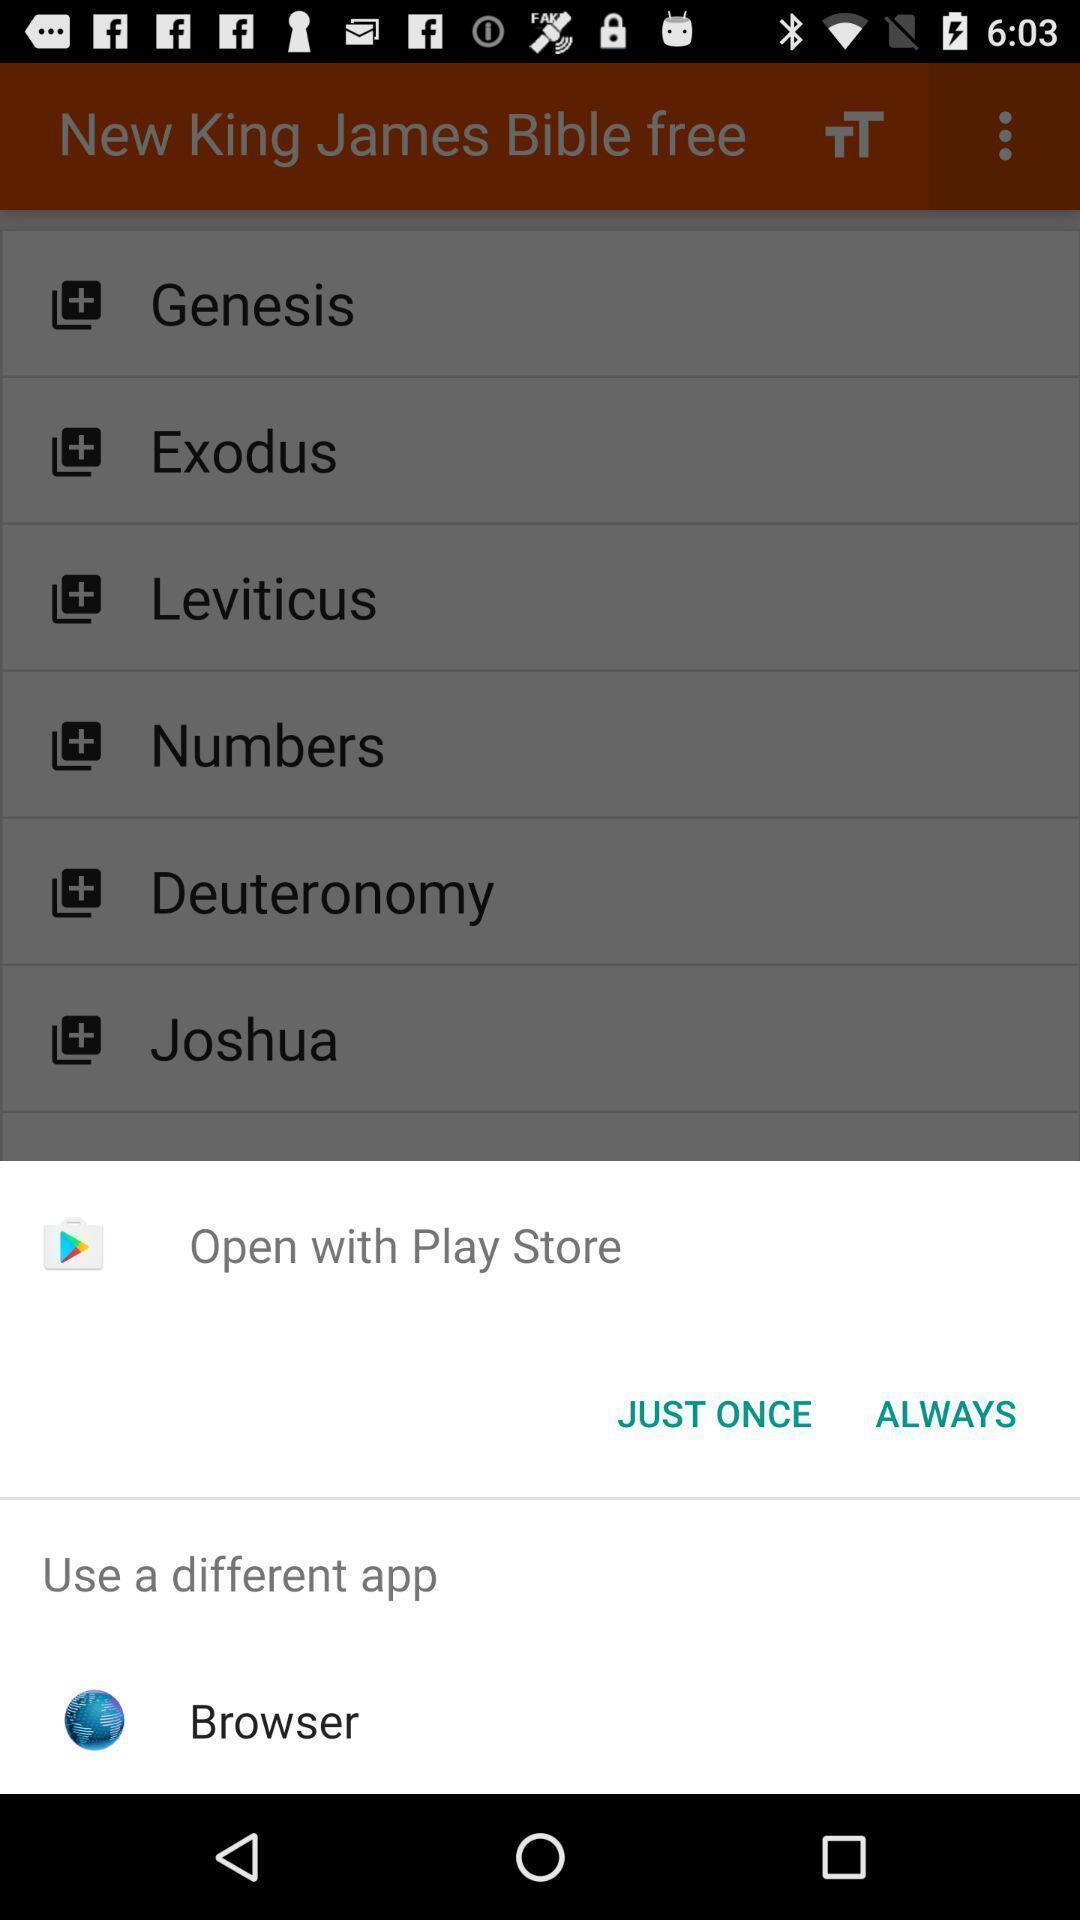Summarize the information in this screenshot. Pop-up widget showing options to open the browser. 